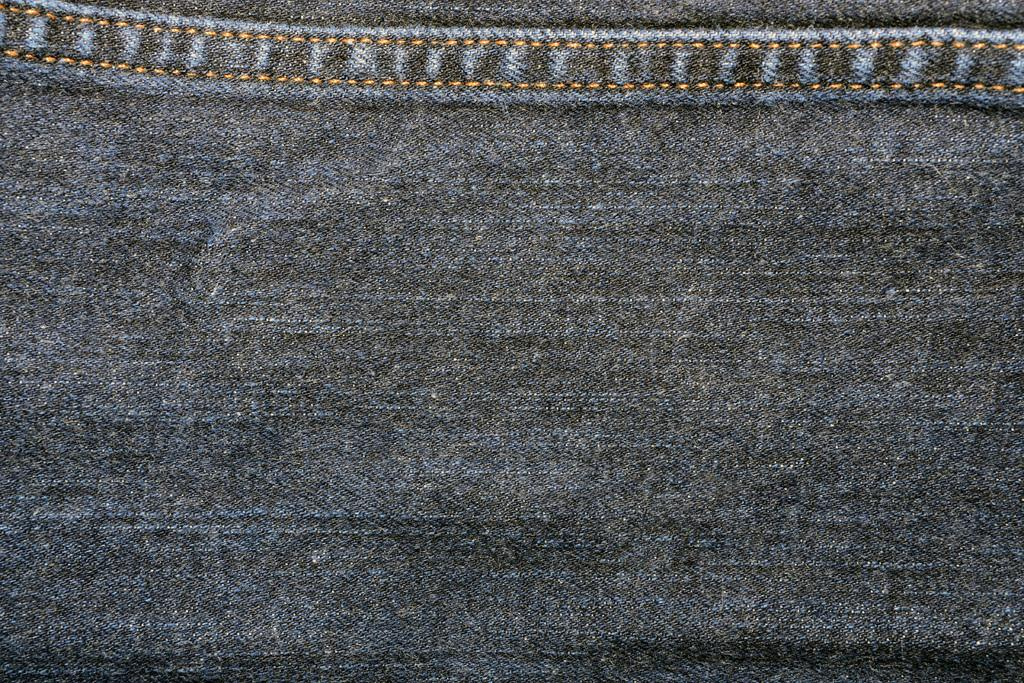What type of clothing is visible in the image? There is a jeans cloth in the image. Can you see someone jumping in the image? There is no person or action of jumping visible in the image; it only features a jeans cloth. What type of neck accessory is present in the image? There is no neck accessory present in the image; it only features a jeans cloth. 